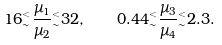<formula> <loc_0><loc_0><loc_500><loc_500>1 6 { ^ { < } _ { \sim } } { \frac { \mu _ { 1 } } { \mu _ { 2 } } } { ^ { < } _ { \sim } } 3 2 , \quad 0 . 4 4 { ^ { < } _ { \sim } } { \frac { \mu _ { 3 } } { \mu _ { 4 } } } { ^ { < } _ { \sim } } 2 . 3 .</formula> 